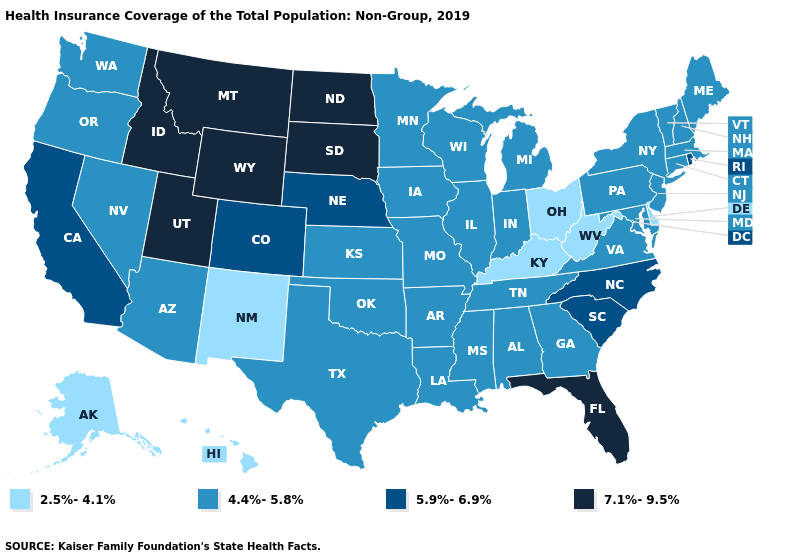Does Delaware have a lower value than North Carolina?
Answer briefly. Yes. Name the states that have a value in the range 5.9%-6.9%?
Answer briefly. California, Colorado, Nebraska, North Carolina, Rhode Island, South Carolina. What is the value of Missouri?
Quick response, please. 4.4%-5.8%. Among the states that border Ohio , which have the highest value?
Answer briefly. Indiana, Michigan, Pennsylvania. What is the value of Louisiana?
Short answer required. 4.4%-5.8%. Which states have the highest value in the USA?
Quick response, please. Florida, Idaho, Montana, North Dakota, South Dakota, Utah, Wyoming. Which states have the highest value in the USA?
Give a very brief answer. Florida, Idaho, Montana, North Dakota, South Dakota, Utah, Wyoming. Is the legend a continuous bar?
Concise answer only. No. What is the lowest value in the USA?
Be succinct. 2.5%-4.1%. Name the states that have a value in the range 7.1%-9.5%?
Short answer required. Florida, Idaho, Montana, North Dakota, South Dakota, Utah, Wyoming. Among the states that border Georgia , which have the highest value?
Answer briefly. Florida. What is the value of New Mexico?
Keep it brief. 2.5%-4.1%. What is the value of Wisconsin?
Be succinct. 4.4%-5.8%. What is the value of Michigan?
Answer briefly. 4.4%-5.8%. What is the lowest value in the USA?
Quick response, please. 2.5%-4.1%. 